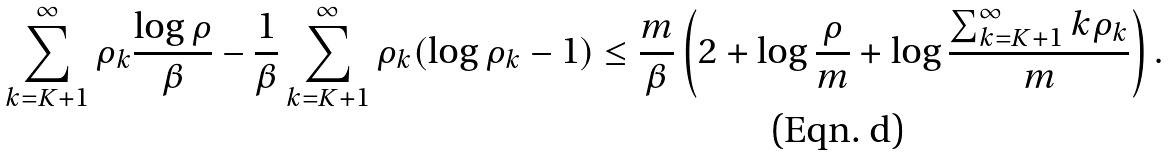Convert formula to latex. <formula><loc_0><loc_0><loc_500><loc_500>\sum _ { k = K + 1 } ^ { \infty } \rho _ { k } \frac { \log \rho } { \beta } - \frac { 1 } { \beta } \sum _ { k = K + 1 } ^ { \infty } \rho _ { k } ( \log \rho _ { k } - 1 ) \leq \frac { m } { \beta } \left ( 2 + \log \frac { \rho } { m } + \log \frac { \sum _ { k = K + 1 } ^ { \infty } k \rho _ { k } } { m } \right ) .</formula> 